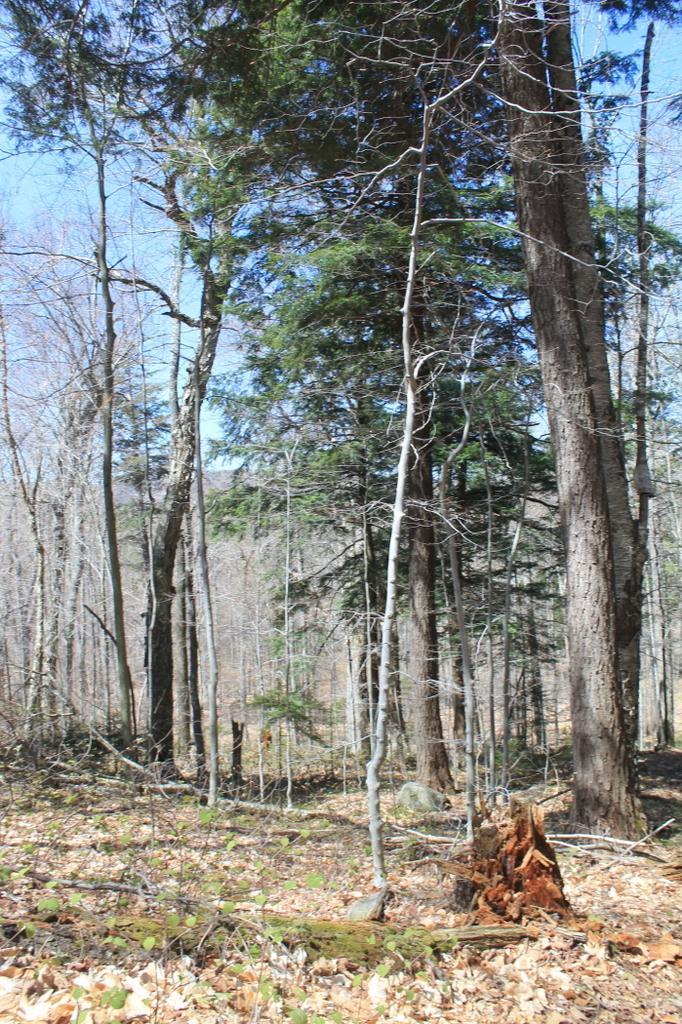Could you give a brief overview of what you see in this image? In this image, we can see some dried leaves on the ground, there are some trees, at the top we can see the blue sky. 